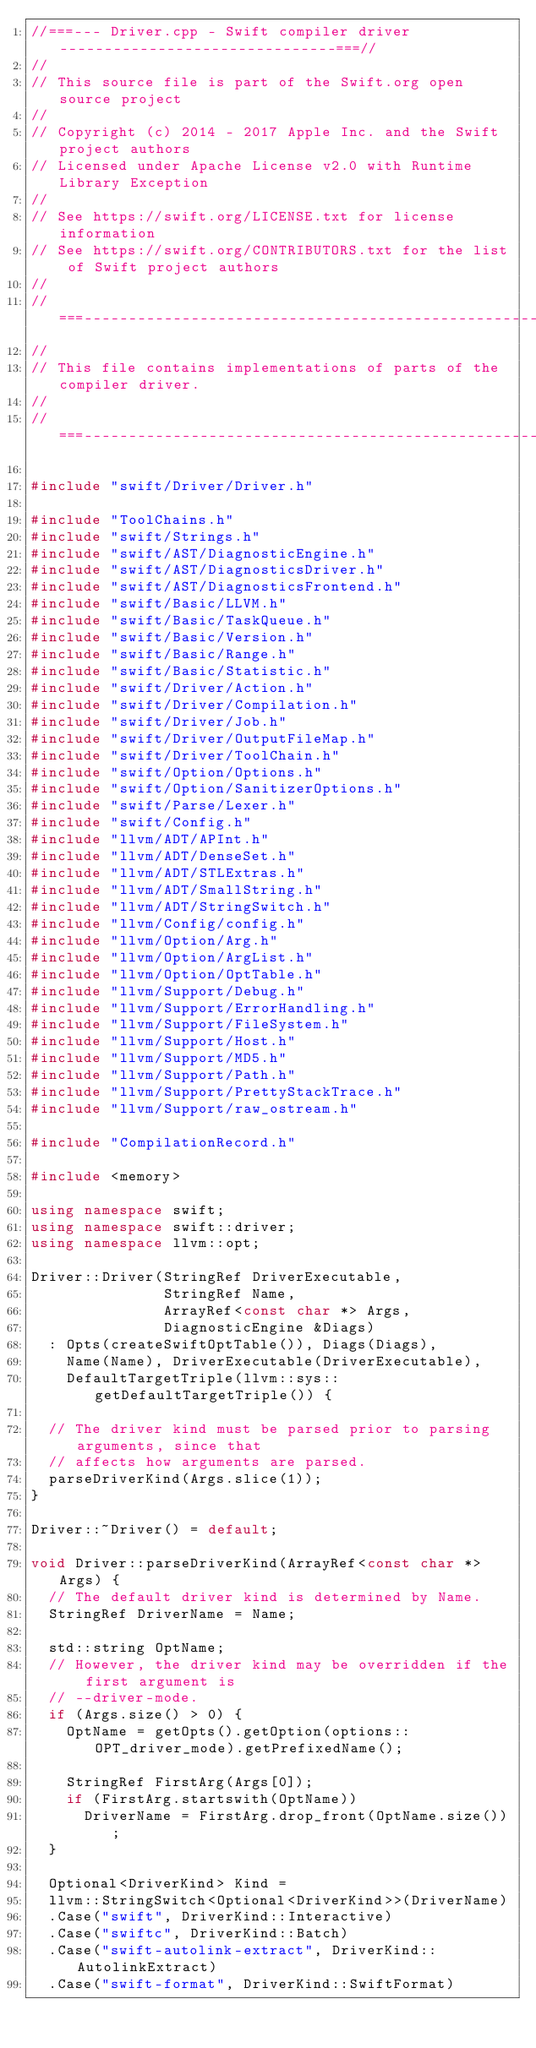<code> <loc_0><loc_0><loc_500><loc_500><_C++_>//===--- Driver.cpp - Swift compiler driver -------------------------------===//
//
// This source file is part of the Swift.org open source project
//
// Copyright (c) 2014 - 2017 Apple Inc. and the Swift project authors
// Licensed under Apache License v2.0 with Runtime Library Exception
//
// See https://swift.org/LICENSE.txt for license information
// See https://swift.org/CONTRIBUTORS.txt for the list of Swift project authors
//
//===----------------------------------------------------------------------===//
//
// This file contains implementations of parts of the compiler driver.
//
//===----------------------------------------------------------------------===//

#include "swift/Driver/Driver.h"

#include "ToolChains.h"
#include "swift/Strings.h"
#include "swift/AST/DiagnosticEngine.h"
#include "swift/AST/DiagnosticsDriver.h"
#include "swift/AST/DiagnosticsFrontend.h"
#include "swift/Basic/LLVM.h"
#include "swift/Basic/TaskQueue.h"
#include "swift/Basic/Version.h"
#include "swift/Basic/Range.h"
#include "swift/Basic/Statistic.h"
#include "swift/Driver/Action.h"
#include "swift/Driver/Compilation.h"
#include "swift/Driver/Job.h"
#include "swift/Driver/OutputFileMap.h"
#include "swift/Driver/ToolChain.h"
#include "swift/Option/Options.h"
#include "swift/Option/SanitizerOptions.h"
#include "swift/Parse/Lexer.h"
#include "swift/Config.h"
#include "llvm/ADT/APInt.h"
#include "llvm/ADT/DenseSet.h"
#include "llvm/ADT/STLExtras.h"
#include "llvm/ADT/SmallString.h"
#include "llvm/ADT/StringSwitch.h"
#include "llvm/Config/config.h"
#include "llvm/Option/Arg.h"
#include "llvm/Option/ArgList.h"
#include "llvm/Option/OptTable.h"
#include "llvm/Support/Debug.h"
#include "llvm/Support/ErrorHandling.h"
#include "llvm/Support/FileSystem.h"
#include "llvm/Support/Host.h"
#include "llvm/Support/MD5.h"
#include "llvm/Support/Path.h"
#include "llvm/Support/PrettyStackTrace.h"
#include "llvm/Support/raw_ostream.h"

#include "CompilationRecord.h"

#include <memory>

using namespace swift;
using namespace swift::driver;
using namespace llvm::opt;

Driver::Driver(StringRef DriverExecutable,
               StringRef Name,
               ArrayRef<const char *> Args,
               DiagnosticEngine &Diags)
  : Opts(createSwiftOptTable()), Diags(Diags),
    Name(Name), DriverExecutable(DriverExecutable),
    DefaultTargetTriple(llvm::sys::getDefaultTargetTriple()) {
      
  // The driver kind must be parsed prior to parsing arguments, since that
  // affects how arguments are parsed.
  parseDriverKind(Args.slice(1));
}

Driver::~Driver() = default;

void Driver::parseDriverKind(ArrayRef<const char *> Args) {
  // The default driver kind is determined by Name.
  StringRef DriverName = Name;

  std::string OptName;
  // However, the driver kind may be overridden if the first argument is
  // --driver-mode.
  if (Args.size() > 0) {
    OptName = getOpts().getOption(options::OPT_driver_mode).getPrefixedName();

    StringRef FirstArg(Args[0]);
    if (FirstArg.startswith(OptName))
      DriverName = FirstArg.drop_front(OptName.size());
  }

  Optional<DriverKind> Kind =
  llvm::StringSwitch<Optional<DriverKind>>(DriverName)
  .Case("swift", DriverKind::Interactive)
  .Case("swiftc", DriverKind::Batch)
  .Case("swift-autolink-extract", DriverKind::AutolinkExtract)
  .Case("swift-format", DriverKind::SwiftFormat)</code> 